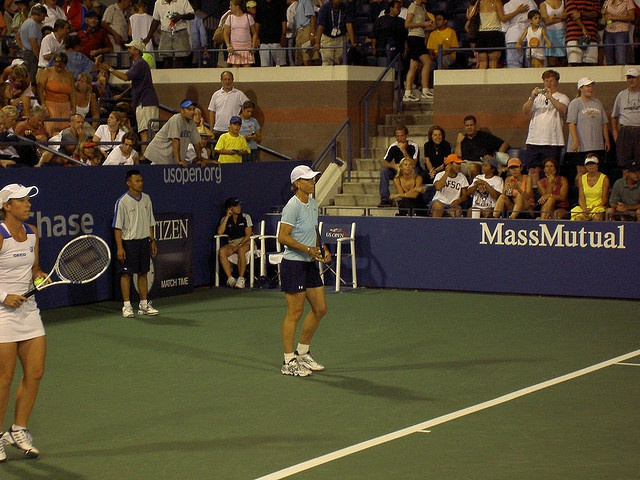Describe the objects in this image and their specific colors. I can see people in black, maroon, and gray tones, people in black, olive, brown, and tan tones, people in black, olive, and darkgray tones, people in black, gray, and maroon tones, and people in black, tan, and maroon tones in this image. 